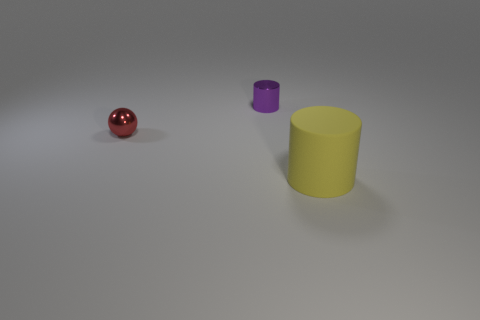How big is the object behind the tiny thing left of the tiny purple shiny cylinder?
Your response must be concise. Small. There is a object that is both to the right of the red thing and behind the big yellow matte thing; how big is it?
Your response must be concise. Small. What number of red objects are the same size as the metallic sphere?
Your response must be concise. 0. What number of rubber objects are small balls or purple cylinders?
Provide a succinct answer. 0. The cylinder that is left of the object that is in front of the red sphere is made of what material?
Give a very brief answer. Metal. How many things are small red shiny spheres or objects that are on the right side of the red shiny thing?
Your answer should be very brief. 3. What is the size of the cylinder that is the same material as the tiny red thing?
Provide a succinct answer. Small. How many purple things are small objects or big metallic things?
Your answer should be compact. 1. Are there any other things that are made of the same material as the big cylinder?
Your answer should be compact. No. There is a object that is in front of the tiny red metal object; is it the same shape as the small metal object left of the small purple metallic thing?
Offer a very short reply. No. 